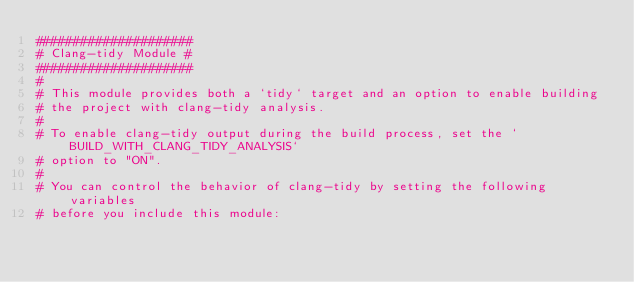Convert code to text. <code><loc_0><loc_0><loc_500><loc_500><_CMake_>#####################
# Clang-tidy Module #
#####################
#
# This module provides both a `tidy` target and an option to enable building
# the project with clang-tidy analysis.
#
# To enable clang-tidy output during the build process, set the `BUILD_WITH_CLANG_TIDY_ANALYSIS`
# option to "ON".
#
# You can control the behavior of clang-tidy by setting the following variables
# before you include this module:</code> 